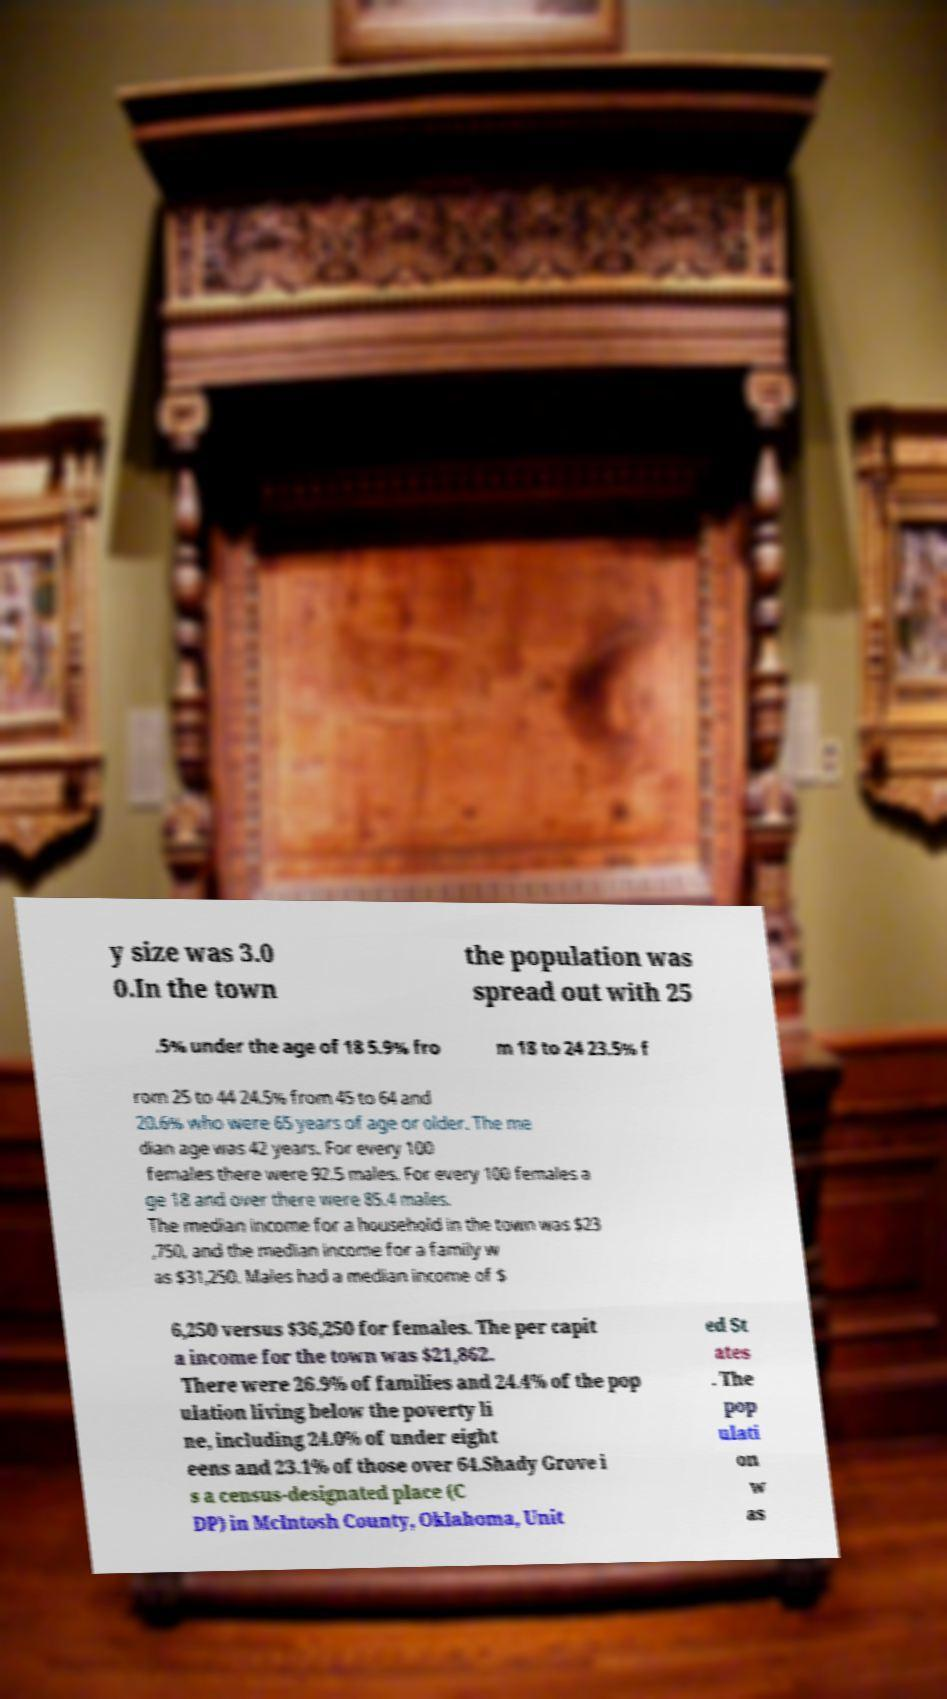For documentation purposes, I need the text within this image transcribed. Could you provide that? y size was 3.0 0.In the town the population was spread out with 25 .5% under the age of 18 5.9% fro m 18 to 24 23.5% f rom 25 to 44 24.5% from 45 to 64 and 20.6% who were 65 years of age or older. The me dian age was 42 years. For every 100 females there were 92.5 males. For every 100 females a ge 18 and over there were 85.4 males. The median income for a household in the town was $23 ,750, and the median income for a family w as $31,250. Males had a median income of $ 6,250 versus $36,250 for females. The per capit a income for the town was $21,862. There were 26.9% of families and 24.4% of the pop ulation living below the poverty li ne, including 24.0% of under eight eens and 23.1% of those over 64.Shady Grove i s a census-designated place (C DP) in McIntosh County, Oklahoma, Unit ed St ates . The pop ulati on w as 